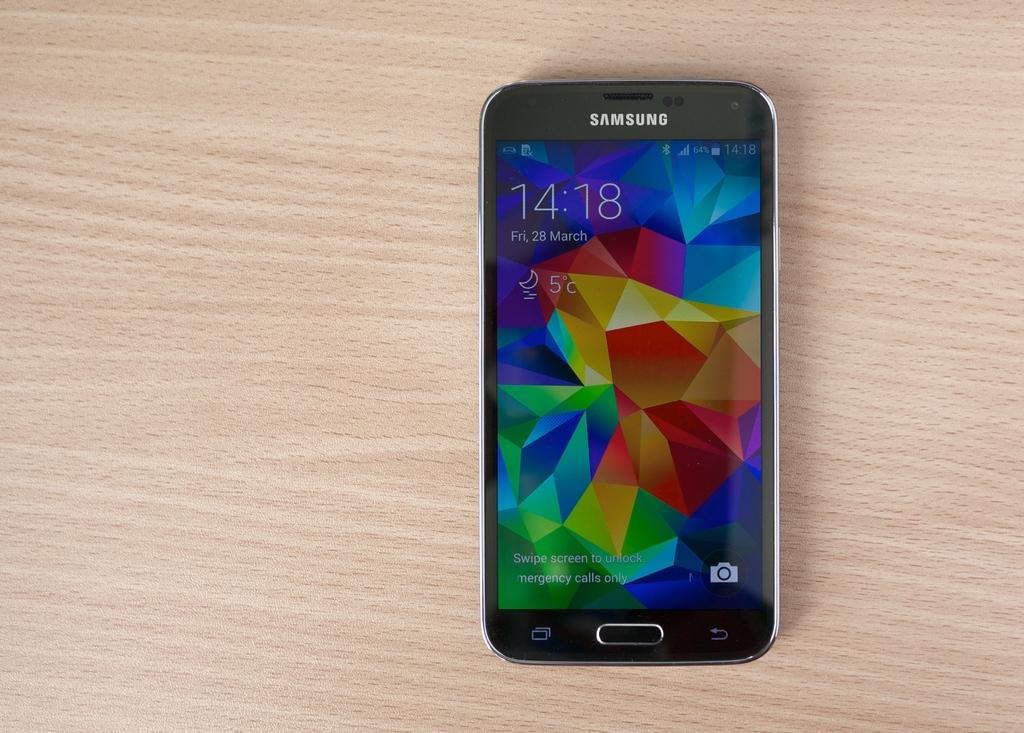Provide a one-sentence caption for the provided image. A Samsung phone with a colorful screen sits on a wood table. 